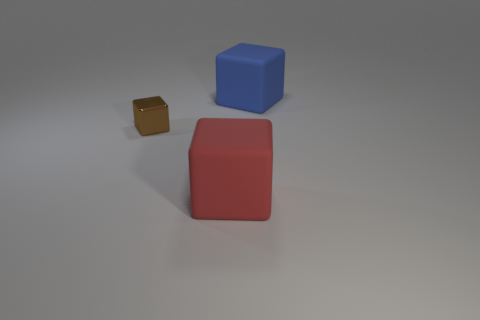Is the material of the thing behind the tiny metallic thing the same as the big cube that is in front of the tiny block?
Your answer should be compact. Yes. Is the number of small brown metal blocks on the left side of the metallic object greater than the number of large blue rubber cubes that are behind the large blue rubber object?
Your response must be concise. No. Is there any other thing that is the same shape as the large red thing?
Ensure brevity in your answer.  Yes. What is the material of the cube that is on the right side of the tiny brown cube and behind the big red object?
Provide a short and direct response. Rubber. Is the large blue object made of the same material as the object in front of the tiny brown metal cube?
Offer a very short reply. Yes. Is there anything else that is the same size as the blue matte thing?
Your answer should be very brief. Yes. How many things are metal objects or large rubber blocks that are in front of the tiny metallic object?
Give a very brief answer. 2. There is a rubber object that is in front of the large blue matte object; is it the same size as the metal cube that is in front of the blue object?
Your answer should be compact. No. How many other things are the same color as the tiny shiny thing?
Keep it short and to the point. 0. Is the size of the brown metallic cube the same as the rubber object behind the red cube?
Provide a succinct answer. No. 